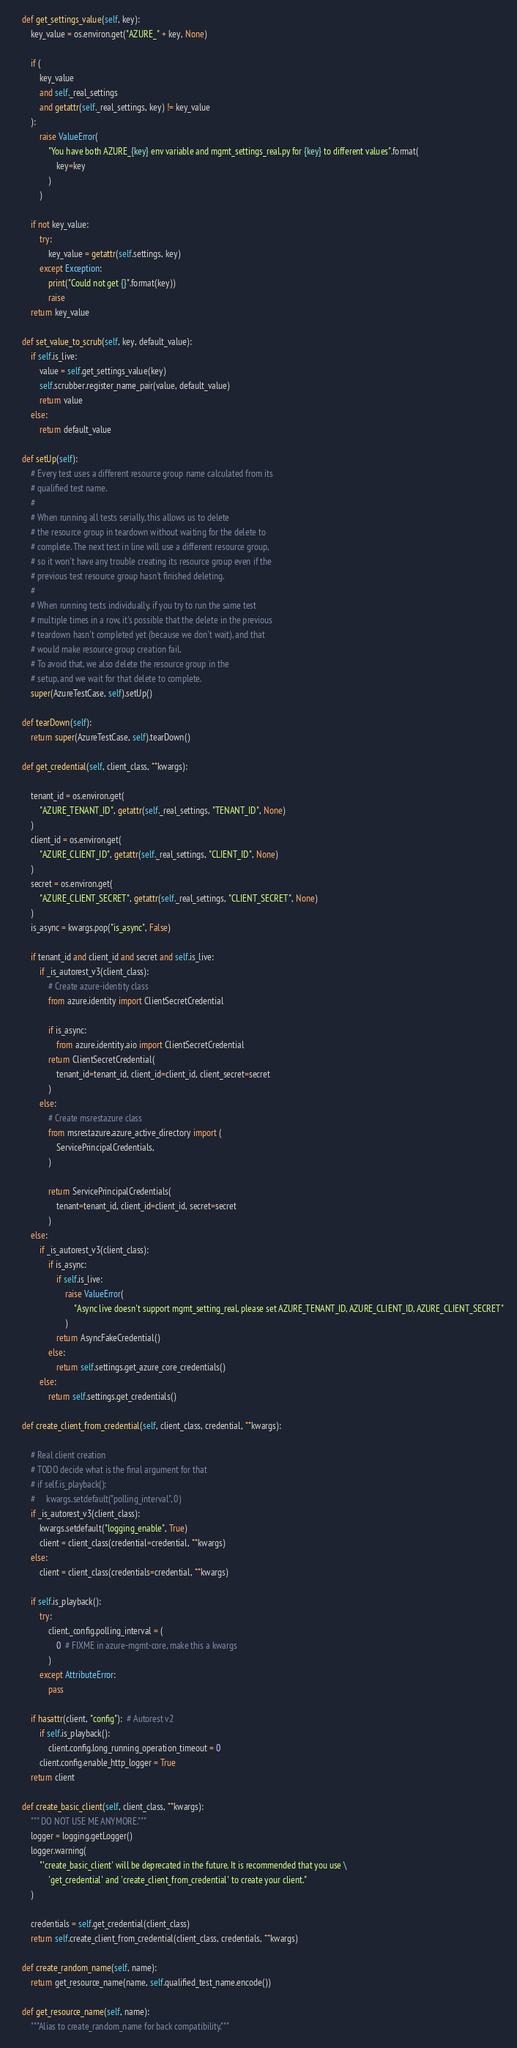<code> <loc_0><loc_0><loc_500><loc_500><_Python_>    def get_settings_value(self, key):
        key_value = os.environ.get("AZURE_" + key, None)

        if (
            key_value
            and self._real_settings
            and getattr(self._real_settings, key) != key_value
        ):
            raise ValueError(
                "You have both AZURE_{key} env variable and mgmt_settings_real.py for {key} to different values".format(
                    key=key
                )
            )

        if not key_value:
            try:
                key_value = getattr(self.settings, key)
            except Exception:
                print("Could not get {}".format(key))
                raise
        return key_value

    def set_value_to_scrub(self, key, default_value):
        if self.is_live:
            value = self.get_settings_value(key)
            self.scrubber.register_name_pair(value, default_value)
            return value
        else:
            return default_value

    def setUp(self):
        # Every test uses a different resource group name calculated from its
        # qualified test name.
        #
        # When running all tests serially, this allows us to delete
        # the resource group in teardown without waiting for the delete to
        # complete. The next test in line will use a different resource group,
        # so it won't have any trouble creating its resource group even if the
        # previous test resource group hasn't finished deleting.
        #
        # When running tests individually, if you try to run the same test
        # multiple times in a row, it's possible that the delete in the previous
        # teardown hasn't completed yet (because we don't wait), and that
        # would make resource group creation fail.
        # To avoid that, we also delete the resource group in the
        # setup, and we wait for that delete to complete.
        super(AzureTestCase, self).setUp()

    def tearDown(self):
        return super(AzureTestCase, self).tearDown()

    def get_credential(self, client_class, **kwargs):

        tenant_id = os.environ.get(
            "AZURE_TENANT_ID", getattr(self._real_settings, "TENANT_ID", None)
        )
        client_id = os.environ.get(
            "AZURE_CLIENT_ID", getattr(self._real_settings, "CLIENT_ID", None)
        )
        secret = os.environ.get(
            "AZURE_CLIENT_SECRET", getattr(self._real_settings, "CLIENT_SECRET", None)
        )
        is_async = kwargs.pop("is_async", False)

        if tenant_id and client_id and secret and self.is_live:
            if _is_autorest_v3(client_class):
                # Create azure-identity class
                from azure.identity import ClientSecretCredential

                if is_async:
                    from azure.identity.aio import ClientSecretCredential
                return ClientSecretCredential(
                    tenant_id=tenant_id, client_id=client_id, client_secret=secret
                )
            else:
                # Create msrestazure class
                from msrestazure.azure_active_directory import (
                    ServicePrincipalCredentials,
                )

                return ServicePrincipalCredentials(
                    tenant=tenant_id, client_id=client_id, secret=secret
                )
        else:
            if _is_autorest_v3(client_class):
                if is_async:
                    if self.is_live:
                        raise ValueError(
                            "Async live doesn't support mgmt_setting_real, please set AZURE_TENANT_ID, AZURE_CLIENT_ID, AZURE_CLIENT_SECRET"
                        )
                    return AsyncFakeCredential()
                else:
                    return self.settings.get_azure_core_credentials()
            else:
                return self.settings.get_credentials()

    def create_client_from_credential(self, client_class, credential, **kwargs):

        # Real client creation
        # TODO decide what is the final argument for that
        # if self.is_playback():
        #     kwargs.setdefault("polling_interval", 0)
        if _is_autorest_v3(client_class):
            kwargs.setdefault("logging_enable", True)
            client = client_class(credential=credential, **kwargs)
        else:
            client = client_class(credentials=credential, **kwargs)

        if self.is_playback():
            try:
                client._config.polling_interval = (
                    0  # FIXME in azure-mgmt-core, make this a kwargs
                )
            except AttributeError:
                pass

        if hasattr(client, "config"):  # Autorest v2
            if self.is_playback():
                client.config.long_running_operation_timeout = 0
            client.config.enable_http_logger = True
        return client

    def create_basic_client(self, client_class, **kwargs):
        """ DO NOT USE ME ANYMORE."""
        logger = logging.getLogger()
        logger.warning(
            "'create_basic_client' will be deprecated in the future. It is recommended that you use \
                'get_credential' and 'create_client_from_credential' to create your client."
        )

        credentials = self.get_credential(client_class)
        return self.create_client_from_credential(client_class, credentials, **kwargs)

    def create_random_name(self, name):
        return get_resource_name(name, self.qualified_test_name.encode())

    def get_resource_name(self, name):
        """Alias to create_random_name for back compatibility."""</code> 